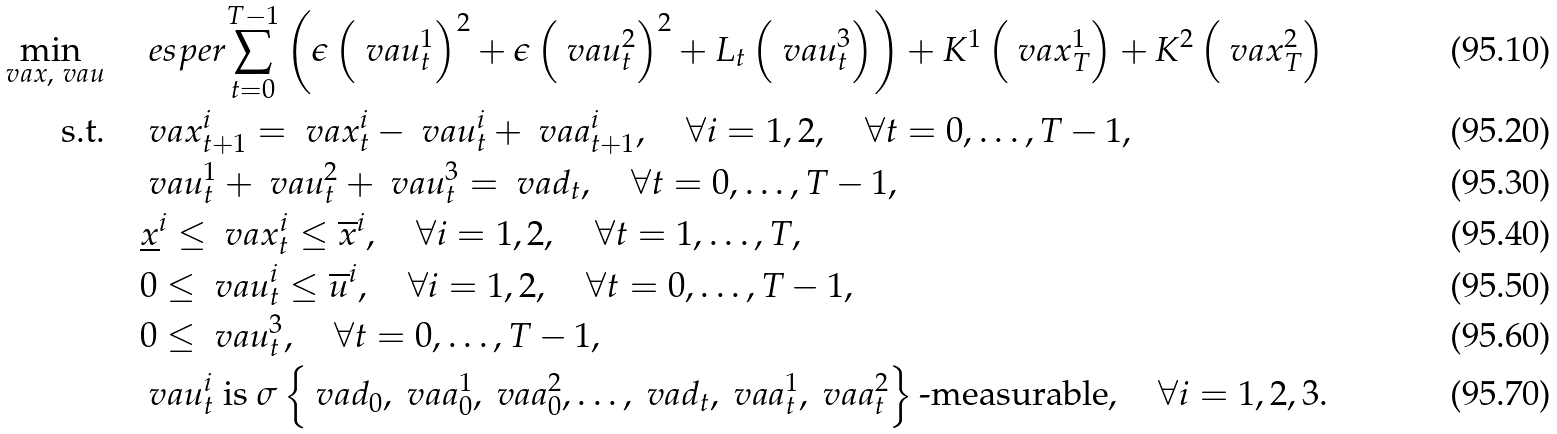<formula> <loc_0><loc_0><loc_500><loc_500>\min _ { \ v a { x } , \ v a { u } } \quad & \ e s p e r { \sum _ { t = 0 } ^ { T - 1 } \left ( \epsilon \left ( \ v a { u } _ { t } ^ { 1 } \right ) ^ { 2 } + \epsilon \left ( \ v a { u } _ { t } ^ { 2 } \right ) ^ { 2 } + L _ { t } \left ( \ v a { u } _ { t } ^ { 3 } \right ) \right ) + K ^ { 1 } \left ( \ v a { x } _ { T } ^ { 1 } \right ) + K ^ { 2 } \left ( \ v a { x } _ { T } ^ { 2 } \right ) } \\ \text {s.t.} \quad & \ v a { x } _ { t + 1 } ^ { i } = \ v a { x } _ { t } ^ { i } - \ v a { u } _ { t } ^ { i } + \ v a { a } _ { t + 1 } ^ { i } , \quad \forall i = 1 , 2 , \quad \forall t = 0 , \dots , T - 1 , \\ & \ v a { u } _ { t } ^ { 1 } + \ v a { u } _ { t } ^ { 2 } + \ v a { u } _ { t } ^ { 3 } = \ v a { d } _ { t } , \quad \forall t = 0 , \dots , T - 1 , \\ & \underline { x } ^ { i } \leq \ v a { x } _ { t } ^ { i } \leq \overline { x } ^ { i } , \quad \forall i = 1 , 2 , \quad \forall t = 1 , \dots , T , \\ & 0 \leq \ v a { u } _ { t } ^ { i } \leq \overline { u } ^ { i } , \quad \forall i = 1 , 2 , \quad \forall t = 0 , \dots , T - 1 , \\ & 0 \leq \ v a { u } _ { t } ^ { 3 } , \quad \forall t = 0 , \dots , T - 1 , \\ & \ v a { u } _ { t } ^ { i } \text { is } \sigma \left \{ \ v a { d } _ { 0 } , \ v a { a } _ { 0 } ^ { 1 } , \ v a { a } _ { 0 } ^ { 2 } , \dots , \ v a { d } _ { t } , \ v a { a } _ { t } ^ { 1 } , \ v a { a } _ { t } ^ { 2 } \right \} \text {-measurable} , \quad \forall i = 1 , 2 , 3 .</formula> 